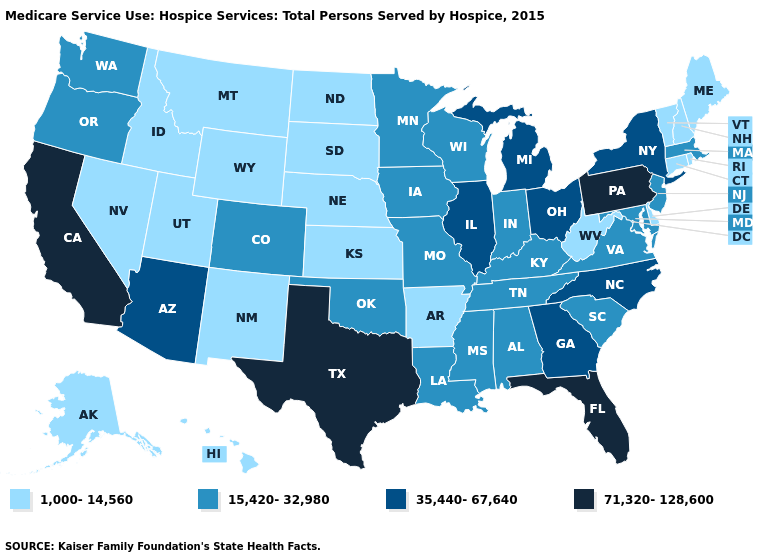Name the states that have a value in the range 1,000-14,560?
Short answer required. Alaska, Arkansas, Connecticut, Delaware, Hawaii, Idaho, Kansas, Maine, Montana, Nebraska, Nevada, New Hampshire, New Mexico, North Dakota, Rhode Island, South Dakota, Utah, Vermont, West Virginia, Wyoming. What is the highest value in the West ?
Keep it brief. 71,320-128,600. Name the states that have a value in the range 1,000-14,560?
Quick response, please. Alaska, Arkansas, Connecticut, Delaware, Hawaii, Idaho, Kansas, Maine, Montana, Nebraska, Nevada, New Hampshire, New Mexico, North Dakota, Rhode Island, South Dakota, Utah, Vermont, West Virginia, Wyoming. Does Florida have the highest value in the South?
Concise answer only. Yes. What is the value of Illinois?
Short answer required. 35,440-67,640. What is the value of New Mexico?
Give a very brief answer. 1,000-14,560. Does the first symbol in the legend represent the smallest category?
Quick response, please. Yes. Does Missouri have a higher value than California?
Keep it brief. No. What is the lowest value in the USA?
Keep it brief. 1,000-14,560. What is the value of Hawaii?
Answer briefly. 1,000-14,560. Which states have the lowest value in the Northeast?
Write a very short answer. Connecticut, Maine, New Hampshire, Rhode Island, Vermont. Is the legend a continuous bar?
Quick response, please. No. What is the value of Wisconsin?
Keep it brief. 15,420-32,980. What is the lowest value in the USA?
Concise answer only. 1,000-14,560. What is the value of Hawaii?
Short answer required. 1,000-14,560. 